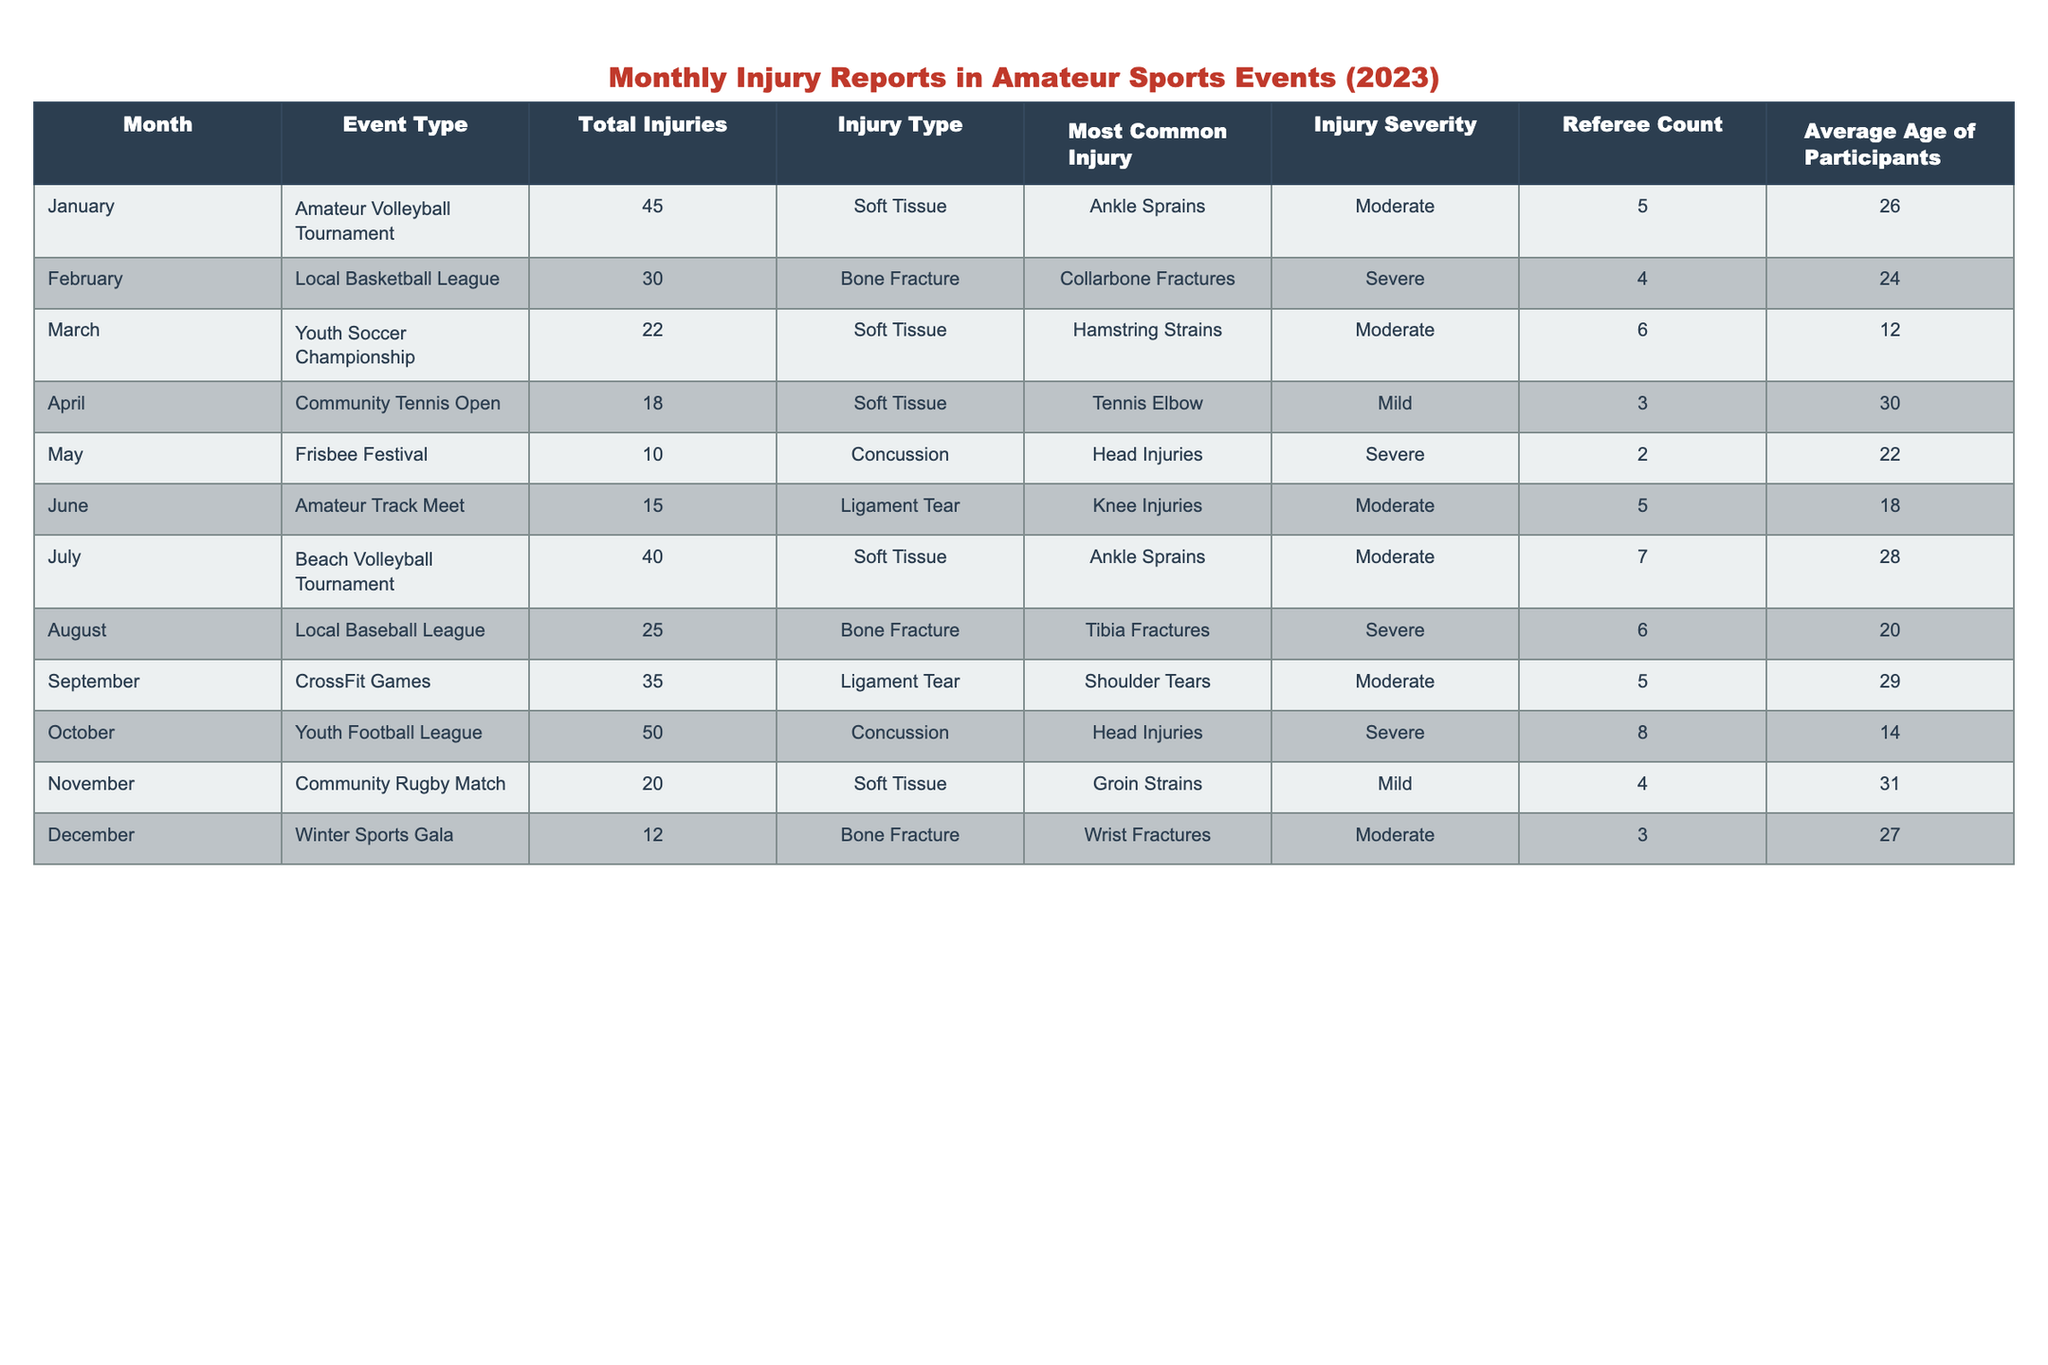What was the most common injury reported in the Amateur Volleyball Tournament? Looking at the table, the most common injury in the Amateur Volleyball Tournament is listed as Ankle Sprains, which corresponds to the entry for January under "Most Common Injury."
Answer: Ankle Sprains Which month had the highest number of total injuries? By comparing the "Total Injuries" for each month, it's evident that October has the highest value with 50 injuries, which is more than any other month listed.
Answer: October How many injuries were reported for the Local Baseball League? The table indicates that the Local Baseball League, which occurred in August, had a total of 25 injuries reported.
Answer: 25 What is the average age of participants in the Youth Soccer Championship? According to the table, the average age of participants in the Youth Soccer Championship, held in March, is 12 years.
Answer: 12 True or False: The Community Rugby Match in November had more severe injuries than the Winter Sports Gala in December. The Community Rugby Match had no severe injuries reported (listed as Mild), while the Winter Sports Gala, which occurred in December, included an entry for Bone Fracture classified as Moderate. Since "severe" injuries were not reported in the rugby match, the statement is false.
Answer: False What is the total number of injuries reported for all events in the first half of the year (January to June)? The total injuries for the first half of the year can be calculated as follows: January (45) + February (30) + March (22) + April (18) + May (10) + June (15) = 140.
Answer: 140 How do the total injuries in October compare to the average number of injuries across all months? The total for October is 50 injuries. To find the average across all months, add all monthly injuries: 45 + 30 + 22 + 18 + 10 + 15 + 40 + 25 + 35 + 50 + 20 + 12 =  359; divide this by 12 (the number of months), yielding approximately 29.92. Comparing, 50 injuries in October exceeds this average.
Answer: Exceeds average What injury severity type was most frequently recorded for the Beach Volleyball Tournament? Looking at the entry for the Beach Volleyball Tournament in July, the injury severity is classified as Moderate. This corresponds to the highest frequency of injuries for that event type, which is consistent in other instances listed under the same category.
Answer: Moderate Which event type reported the least number of injuries in a single month? By examining the total injuries in each month, it is clear that the Frisbee Festival in May had the least number of injuries reported, with a total of 10 injuries noted.
Answer: Frisbee Festival What was the injury type that caused the most severe injuries in the entire report? The events recorded with a Severe injury type include the Local Basketball League (February) and the Youth Football League (October), both showing Bone Fracture and Concussion respectively. Counting them, the Youth Football League had 50 injuries associated with this type, making this the most severe injury reported.
Answer: Concussion 